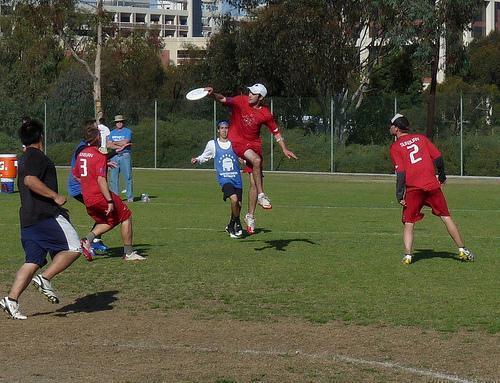How many Frisbee players are wearing red?
Give a very brief answer. 3. 